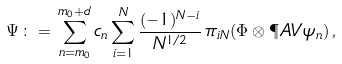<formula> <loc_0><loc_0><loc_500><loc_500>\Psi \, \colon = \, \sum _ { n = m _ { 0 } } ^ { m _ { 0 } + d } c _ { n } \sum _ { i = 1 } ^ { N } \frac { ( - 1 ) ^ { N - i } } { N ^ { 1 / 2 } } \, \pi _ { i N } ( \Phi \otimes \P A V \psi _ { n } ) \, ,</formula> 